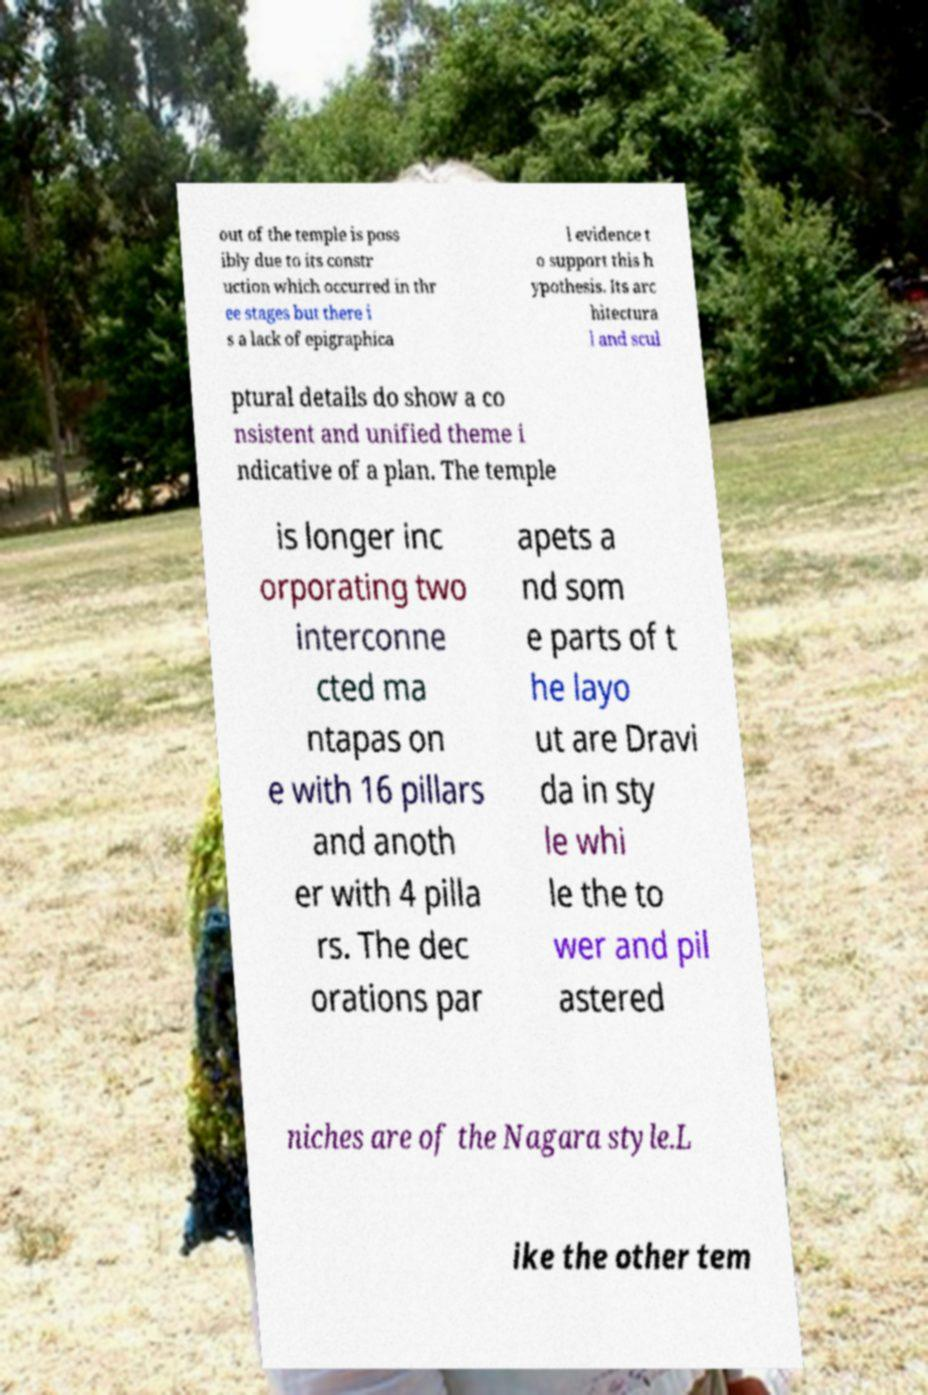Could you assist in decoding the text presented in this image and type it out clearly? out of the temple is poss ibly due to its constr uction which occurred in thr ee stages but there i s a lack of epigraphica l evidence t o support this h ypothesis. Its arc hitectura l and scul ptural details do show a co nsistent and unified theme i ndicative of a plan. The temple is longer inc orporating two interconne cted ma ntapas on e with 16 pillars and anoth er with 4 pilla rs. The dec orations par apets a nd som e parts of t he layo ut are Dravi da in sty le whi le the to wer and pil astered niches are of the Nagara style.L ike the other tem 